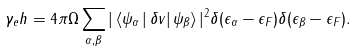<formula> <loc_0><loc_0><loc_500><loc_500>\gamma _ { e } h = 4 \pi \Omega \sum _ { \alpha , \beta } | \, \langle \psi _ { \alpha } \, | \, \delta v | \, \psi _ { \beta } \rangle \, | ^ { 2 } \delta ( \epsilon _ { \alpha } - \epsilon _ { F } ) \delta ( \epsilon _ { \beta } - \epsilon _ { F } ) .</formula> 